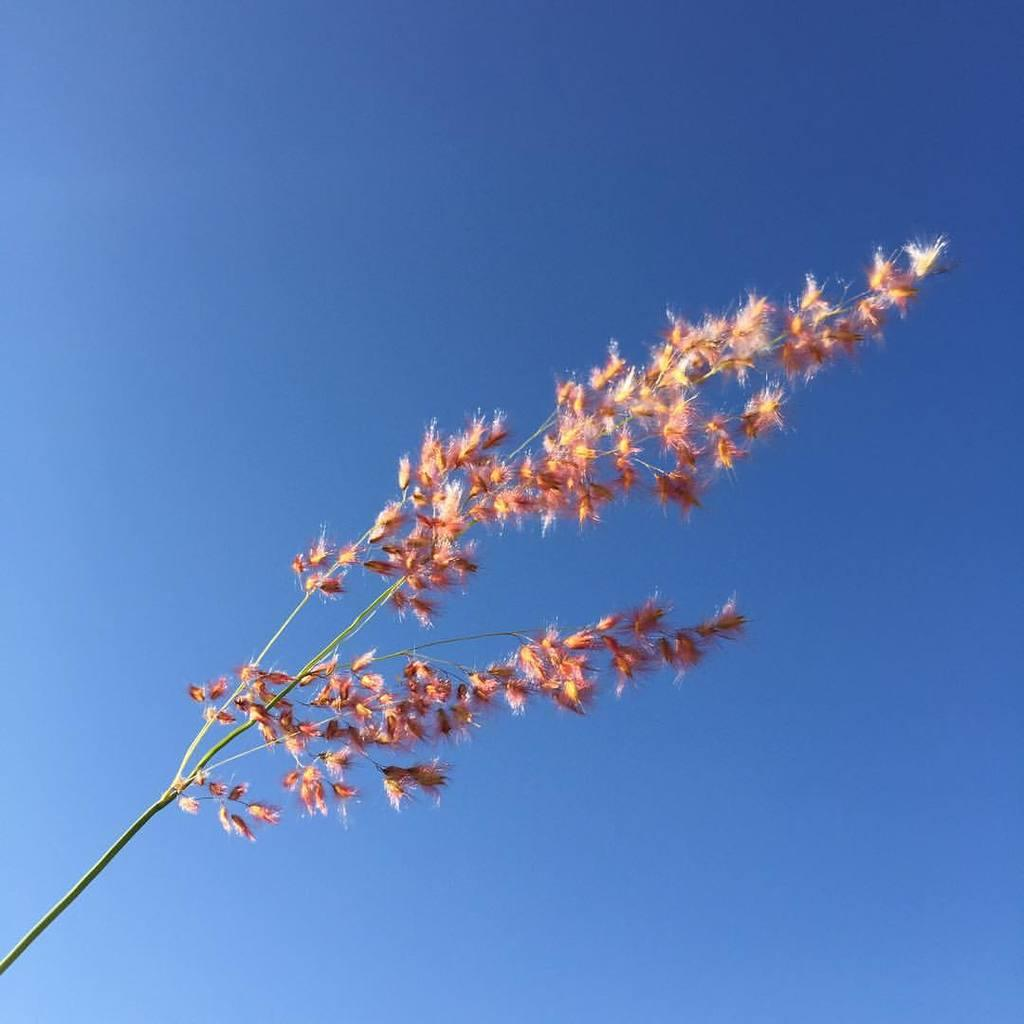What is the main subject of the image? The main subject of the image is a branch of flowers. What color is the background of the image? The background of the image is blue. Where is the faucet located in the image? There is no faucet present in the image. What type of worm can be seen crawling on the branch of flowers in the image? There are no worms present in the image; it features a branch of flowers against a blue background. 